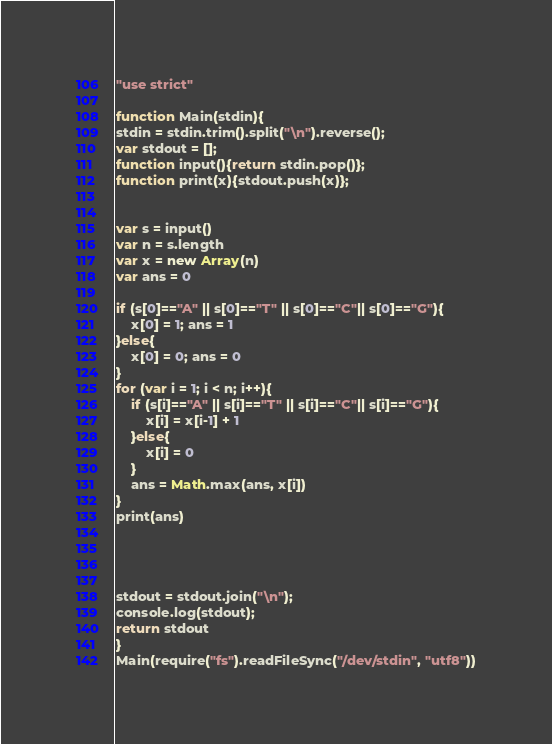<code> <loc_0><loc_0><loc_500><loc_500><_JavaScript_>"use strict"

function Main(stdin){
stdin = stdin.trim().split("\n").reverse();
var stdout = [];
function input(){return stdin.pop()};
function print(x){stdout.push(x)};


var s = input()
var n = s.length
var x = new Array(n)
var ans = 0

if (s[0]=="A" || s[0]=="T" || s[0]=="C"|| s[0]=="G"){
    x[0] = 1; ans = 1
}else{
    x[0] = 0; ans = 0
}
for (var i = 1; i < n; i++){
    if (s[i]=="A" || s[i]=="T" || s[i]=="C"|| s[i]=="G"){
        x[i] = x[i-1] + 1
    }else{
        x[i] = 0
    }
    ans = Math.max(ans, x[i])
}
print(ans)




stdout = stdout.join("\n");
console.log(stdout);
return stdout
}
Main(require("fs").readFileSync("/dev/stdin", "utf8"))</code> 